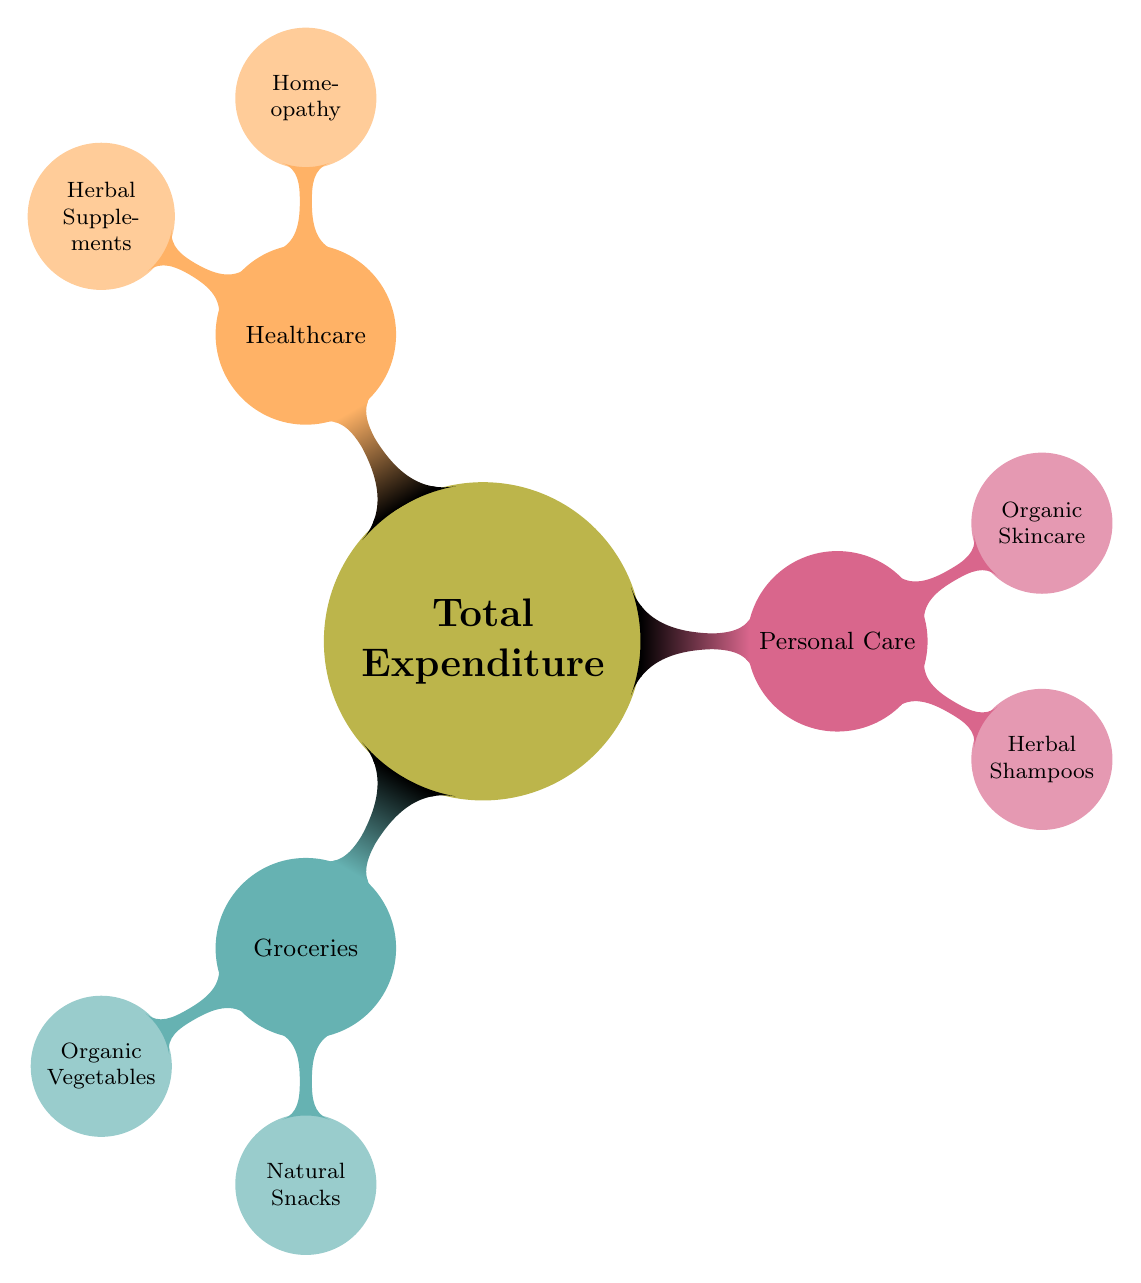What is the primary focus of the diagram? The diagram illustrates the breakdown of monthly household expenditures with a specific emphasis on natural and organic products.
Answer: Total Expenditure How many categories are listed under total expenditure? There are three main categories under total expenditure: Groceries, Personal Care, and Healthcare.
Answer: Three What type of product is included under Groceries? The diagram identifies Organic Vegetables and Natural Snacks as products under the Groceries category.
Answer: Organic Vegetables and Natural Snacks Which category contains Herbal Supplements? The Healthcare category contains Herbal Supplements.
Answer: Healthcare What is the relationship between Personal Care and Organic Skincare? Organic Skincare is a child node under the Personal Care category, indicating it's a subcategory of expenditures in Personal Care.
Answer: Subcategory Which are the parent categories of Natural Snacks? The parent category of Natural Snacks is Groceries, indicating that it falls under the broader classification of grocery expenditure.
Answer: Groceries How many child nodes are associated with the Healthcare category? The Healthcare category has two child nodes, which are Homeopathy and Herbal Supplements.
Answer: Two Which products are classified under Personal Care? Personal Care includes Herbal Shampoos and Organic Skincare as its designated products.
Answer: Herbal Shampoos and Organic Skincare What type of diagram is used here to represent expenditure? This diagram is a mind map, which is used to visually organize hierarchical information about household expenditures.
Answer: Mind map 